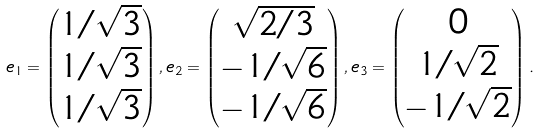<formula> <loc_0><loc_0><loc_500><loc_500>e _ { 1 } = \begin{pmatrix} 1 / \sqrt { 3 } \\ 1 / \sqrt { 3 } \\ 1 / \sqrt { 3 } \end{pmatrix} , e _ { 2 } = \begin{pmatrix} \sqrt { 2 / 3 } \\ - 1 / \sqrt { 6 } \\ - 1 / \sqrt { 6 } \end{pmatrix} , e _ { 3 } = \begin{pmatrix} 0 \\ 1 / \sqrt { 2 } \\ - 1 / \sqrt { 2 } \end{pmatrix} .</formula> 